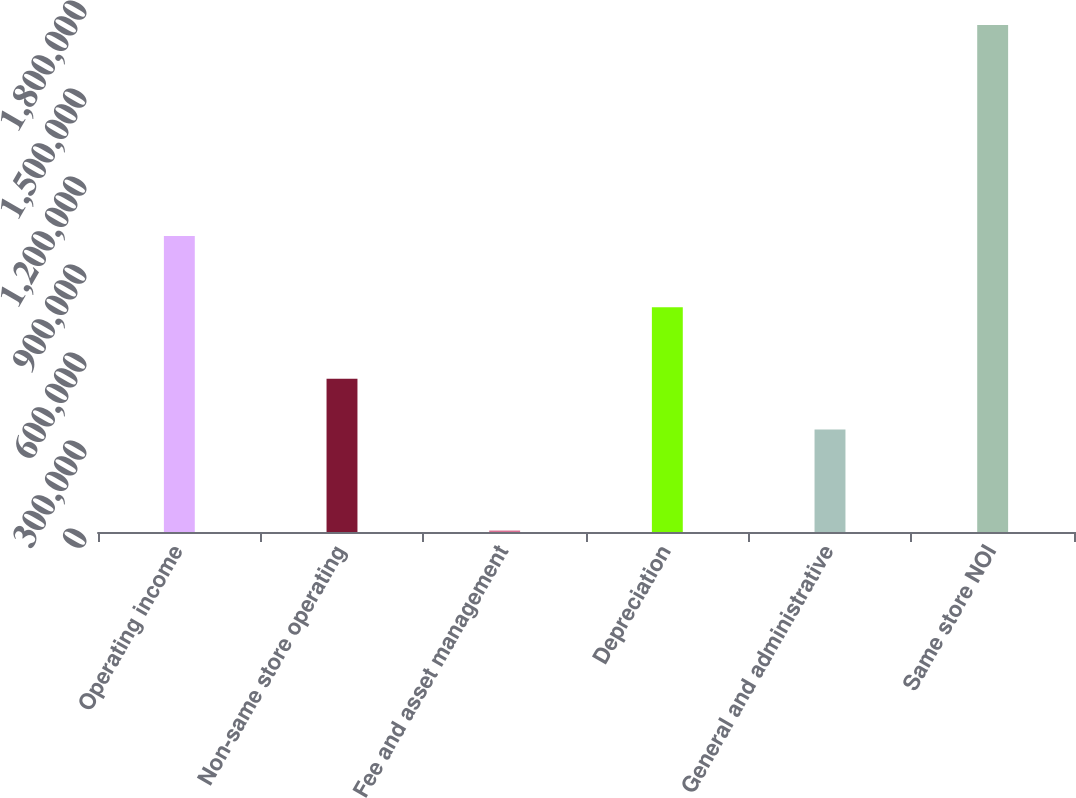Convert chart to OTSL. <chart><loc_0><loc_0><loc_500><loc_500><bar_chart><fcel>Operating income<fcel>Non-same store operating<fcel>Fee and asset management<fcel>Depreciation<fcel>General and administrative<fcel>Same store NOI<nl><fcel>1.00924e+06<fcel>522162<fcel>5021<fcel>765895<fcel>349782<fcel>1.72882e+06<nl></chart> 